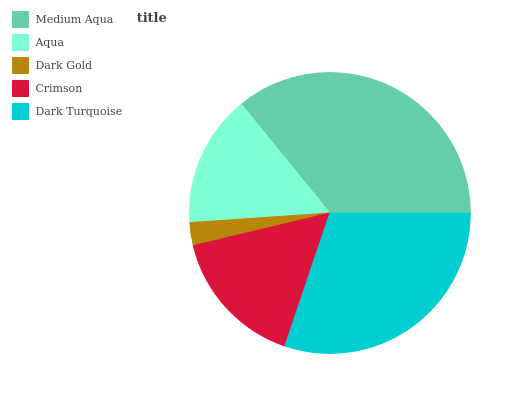Is Dark Gold the minimum?
Answer yes or no. Yes. Is Medium Aqua the maximum?
Answer yes or no. Yes. Is Aqua the minimum?
Answer yes or no. No. Is Aqua the maximum?
Answer yes or no. No. Is Medium Aqua greater than Aqua?
Answer yes or no. Yes. Is Aqua less than Medium Aqua?
Answer yes or no. Yes. Is Aqua greater than Medium Aqua?
Answer yes or no. No. Is Medium Aqua less than Aqua?
Answer yes or no. No. Is Crimson the high median?
Answer yes or no. Yes. Is Crimson the low median?
Answer yes or no. Yes. Is Medium Aqua the high median?
Answer yes or no. No. Is Dark Gold the low median?
Answer yes or no. No. 